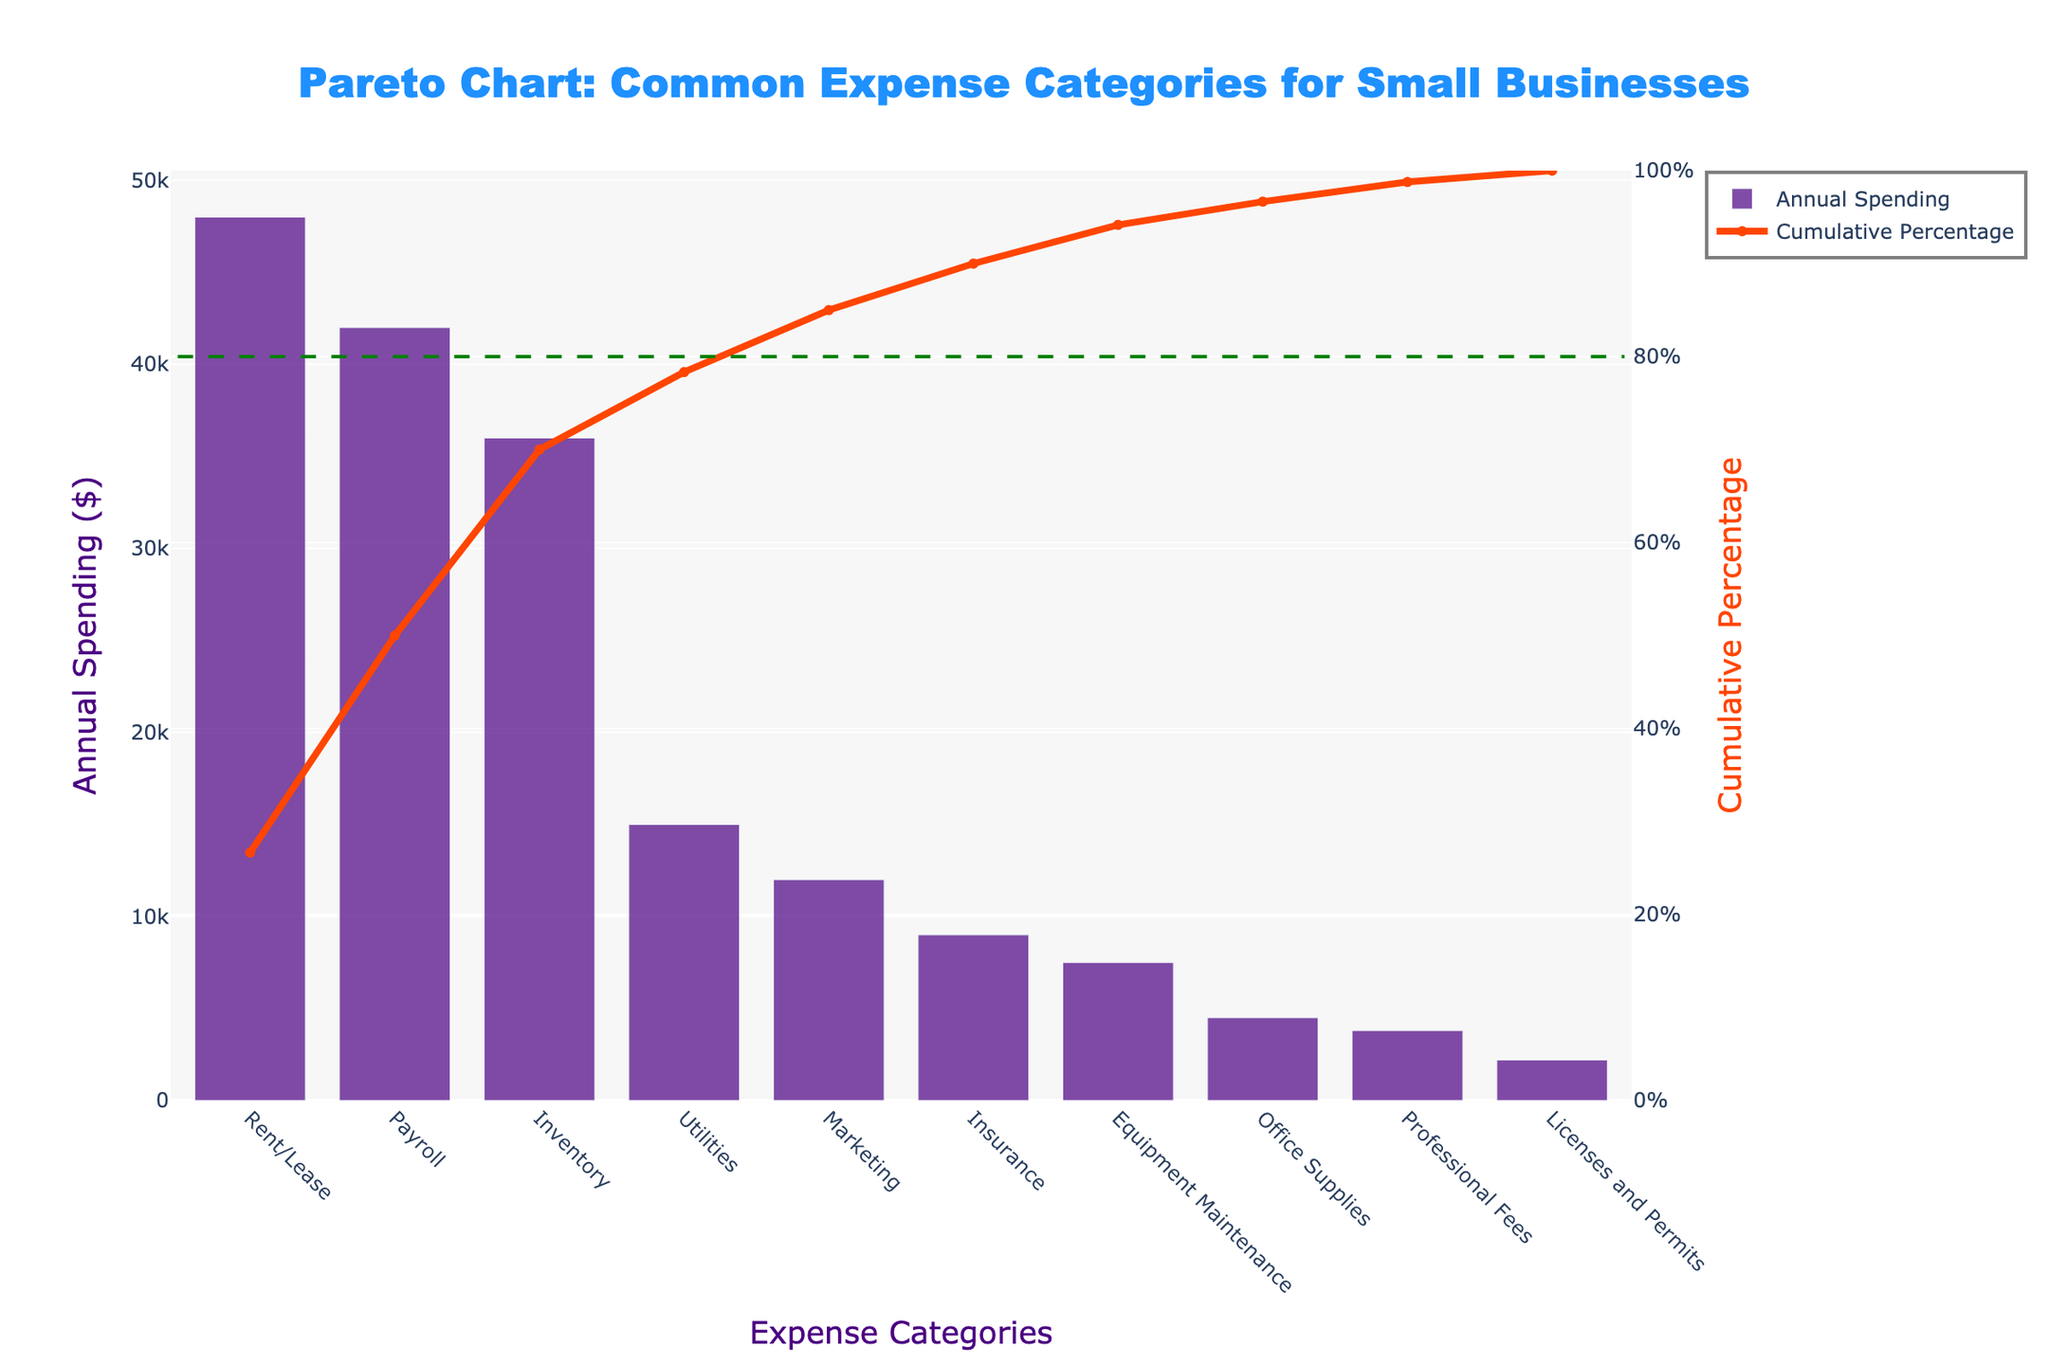What is the title of the figure? The title of the figure is located at the top center of the plot. It reads "Pareto Chart: Common Expense Categories for Small Businesses."
Answer: Pareto Chart: Common Expense Categories for Small Businesses What is the second highest expense category for small businesses? The second highest expense category can be identified by looking at the second tallest bar. It represents Payroll with annual spending of $42,000.
Answer: Payroll What cumulative percentage is reached by the top three expense categories? The cumulative percentage can be found by summing the annual spending of the top three categories (Rent/Lease, Payroll, Inventory), then dividing by the total and multiplying by 100:
48,000 (Rent/Lease) + 42,000 (Payroll) + 36,000 (Inventory) = 126,000
126,000 / (total spending) * 100 = cumulative percentage.
Answer: 76% What color represents the bar chart and the line chart in the figure? The bars are visually represented in purple and the line is represented in red.
Answer: Purple for bars, red for line How does spending on utilities compare to spending on marketing? Compare the heights of the bars for Utilities and Marketing, where Utilities has a higher value.
Answer: Utilities is higher Which expense categories fall below the 80% cumulative percentage line? By looking at where the 80% line intersects the cumulative percentage curve, categories up to Inventory are below this cutoff.
Answer: Rent/Lease, Payroll, Inventory What is the cumulative percentage value at the last data point? The last data point cumulative percentage can be read off where the line chart ends, near 100%.
Answer: 100% Which category has the lowest annual spending, and what is its value? The category with the smallest bar represents the lowest spending, identified as Licenses and Permits with $2,200.
Answer: Licenses and Permits, $2,200 How many categories surpass the 80% cumulative percentage threshold? By observing the cumulative percentage line crossing the 80% mark and counting the subsequent categories, two categories (Office Supplies, Professional Fees) surpass it.
Answer: Two What is the cumulative percentage difference between the highest and the lowest category? The highest category, Rent/Lease, at the start contributes 30%, and the lowest, Licenses and Permits, does not add much beyond the previous categories, effectively moving to 100% cumulative percentage difference:
100% - 30% = 70%.
Answer: 70% 